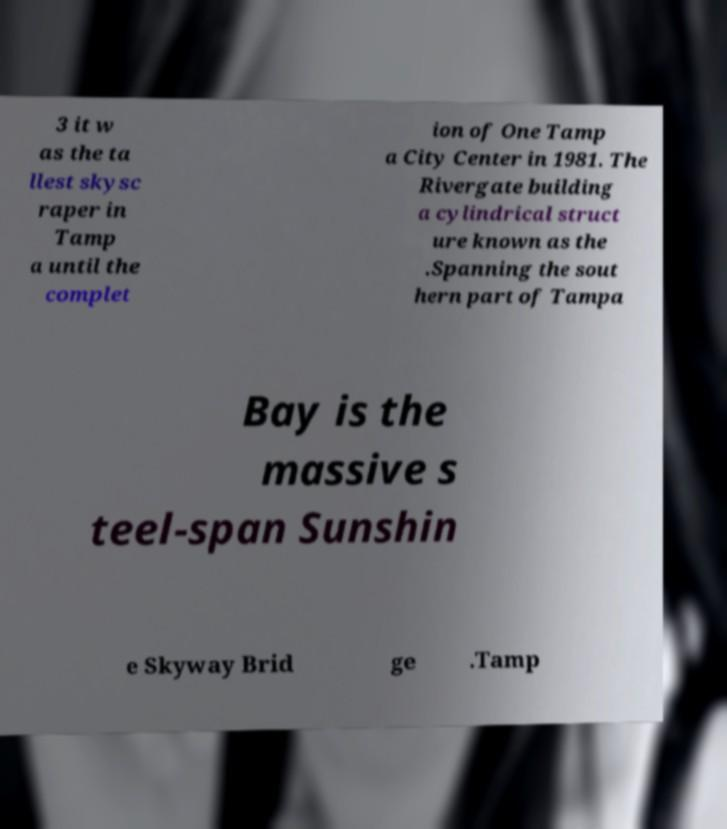Can you accurately transcribe the text from the provided image for me? 3 it w as the ta llest skysc raper in Tamp a until the complet ion of One Tamp a City Center in 1981. The Rivergate building a cylindrical struct ure known as the .Spanning the sout hern part of Tampa Bay is the massive s teel-span Sunshin e Skyway Brid ge .Tamp 